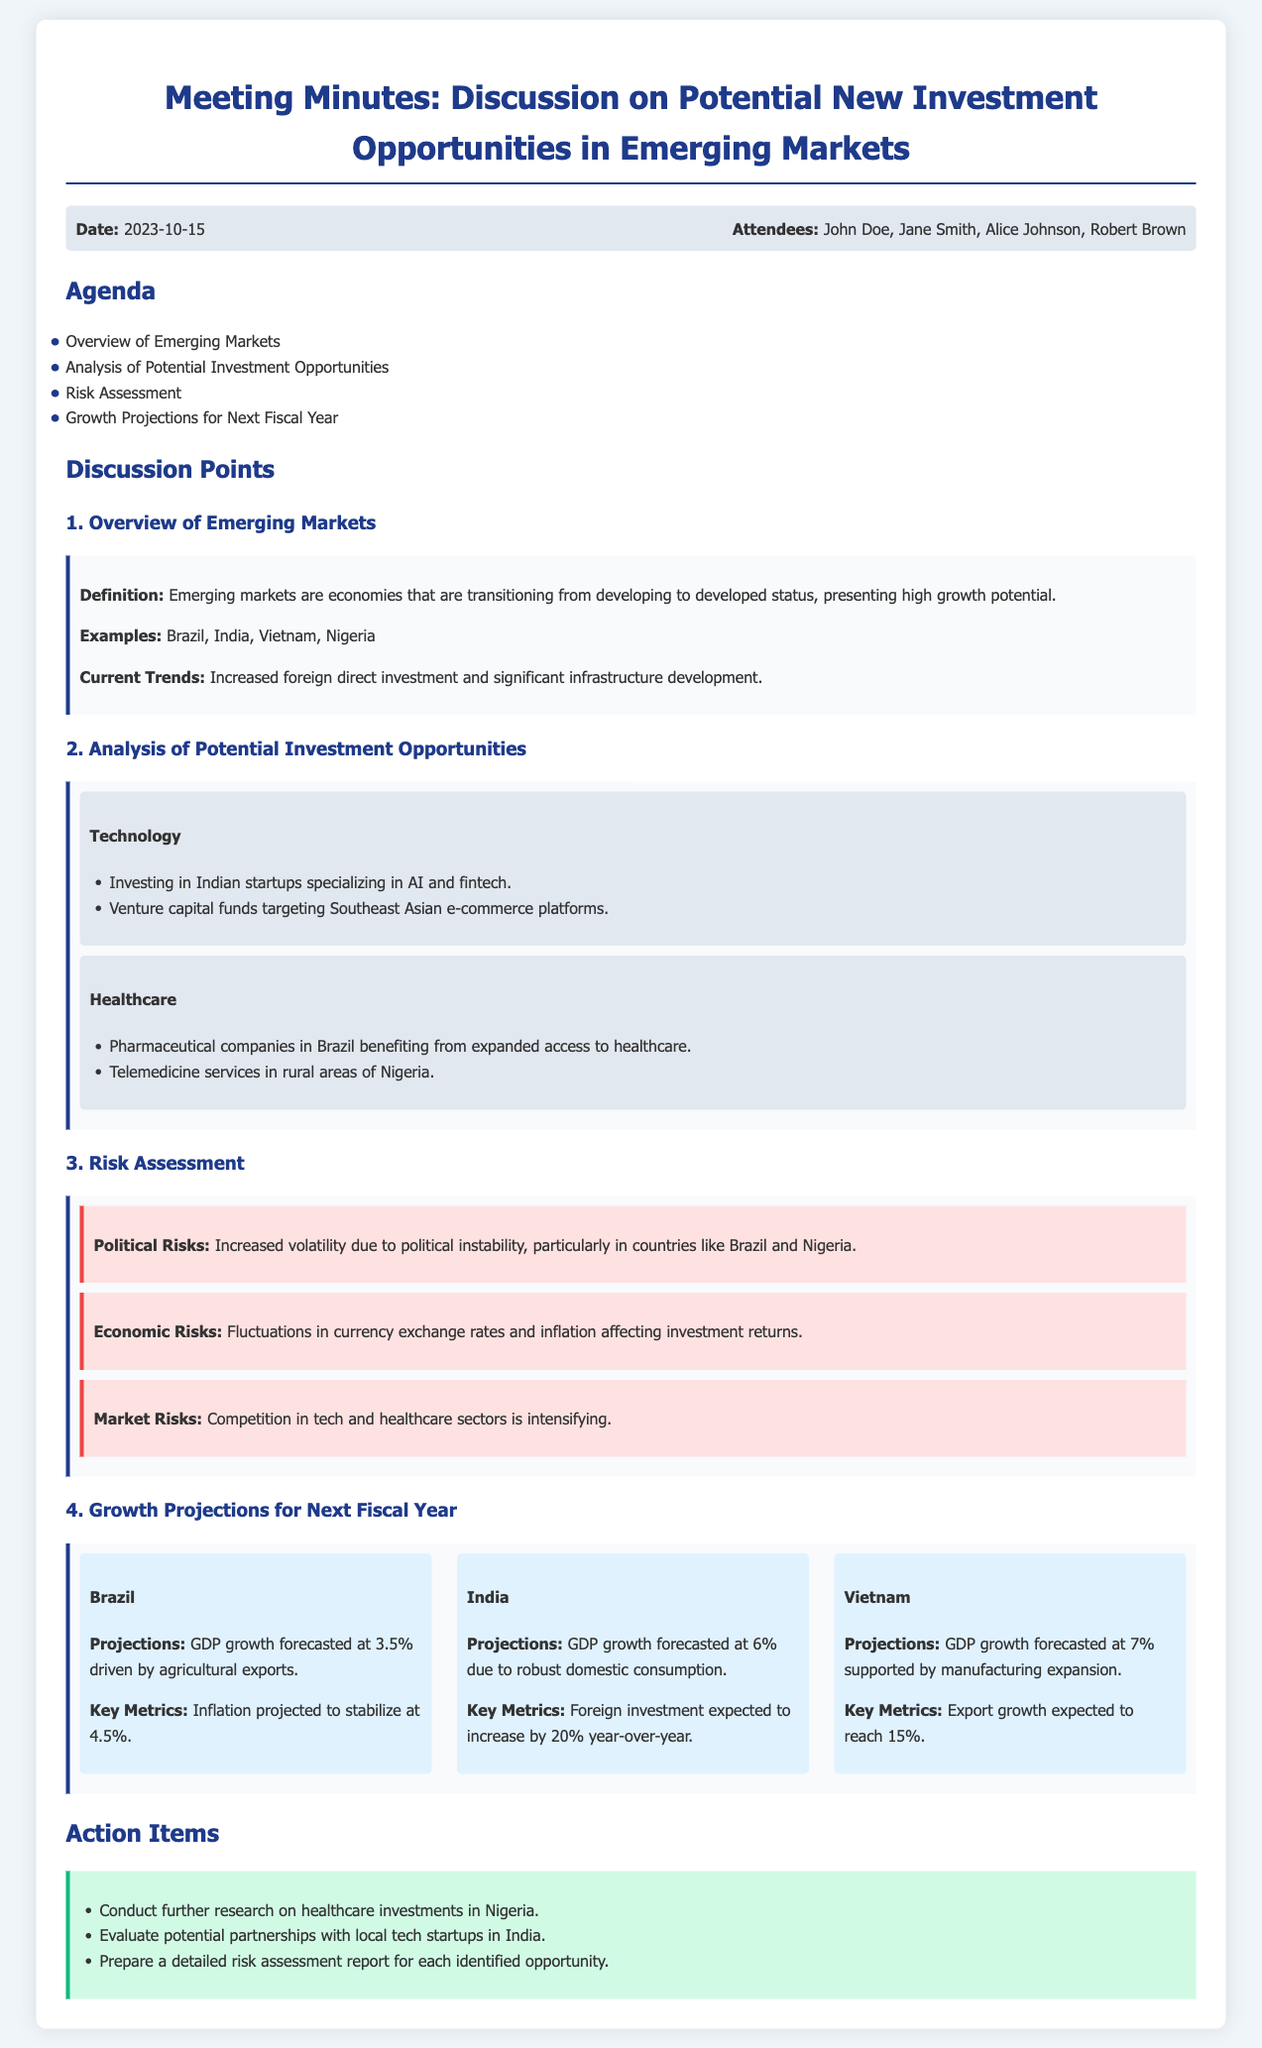What date was the meeting held? The meeting date is mentioned directly in the meta-info section of the document.
Answer: 2023-10-15 Who are the attendees of the meeting? The attendees are listed in the meta-info section, providing their names.
Answer: John Doe, Jane Smith, Alice Johnson, Robert Brown What is the GDP growth forecast for India? The forecasted GDP growth for India is specified within the growth projections section of the document.
Answer: 6% Which sector includes investing in Indian startups? The sector that mentions Indian startups is part of the analysis of potential investment opportunities section.
Answer: Technology What are the political risks associated with Brazil? The political risks for Brazil are detailed in the risk assessment section of the document.
Answer: Increased volatility due to political instability What is the expected inflation rate for Brazil? The expected inflation rate is included in the growth projections section pertaining to Brazil.
Answer: 4.5% What action item involves researching healthcare investments? The action items listed include tasks to be pursued after the meeting.
Answer: Conduct further research on healthcare investments in Nigeria Which country is projected to see a 15% export growth? The export growth projection is found in the growth projections section of the document.
Answer: Vietnam 